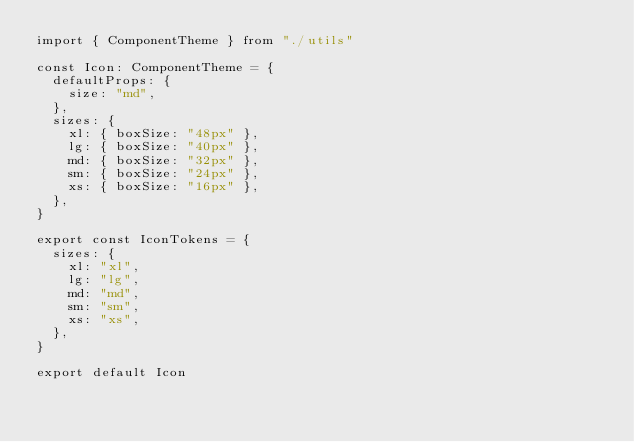<code> <loc_0><loc_0><loc_500><loc_500><_TypeScript_>import { ComponentTheme } from "./utils"

const Icon: ComponentTheme = {
  defaultProps: {
    size: "md",
  },
  sizes: {
    xl: { boxSize: "48px" },
    lg: { boxSize: "40px" },
    md: { boxSize: "32px" },
    sm: { boxSize: "24px" },
    xs: { boxSize: "16px" },
  },
}

export const IconTokens = {
  sizes: {
    xl: "xl",
    lg: "lg",
    md: "md",
    sm: "sm",
    xs: "xs",
  },
}

export default Icon
</code> 